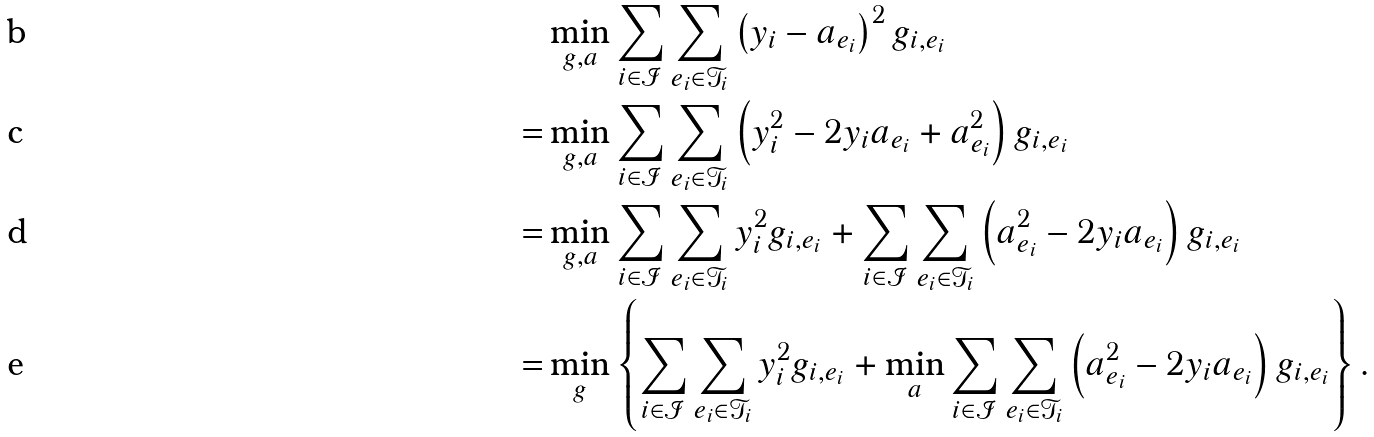<formula> <loc_0><loc_0><loc_500><loc_500>& \min _ { g , a } \sum _ { i \in \mathcal { I } } \sum _ { e _ { i } \in \mathcal { T } _ { i } } \left ( y _ { i } - a _ { e _ { i } } \right ) ^ { 2 } g _ { i , e _ { i } } \\ = & \min _ { g , a } \sum _ { i \in \mathcal { I } } \sum _ { e _ { i } \in \mathcal { T } _ { i } } \left ( y _ { i } ^ { 2 } - 2 y _ { i } a _ { e _ { i } } + a _ { e _ { i } } ^ { 2 } \right ) g _ { i , e _ { i } } \\ = & \min _ { g , a } \sum _ { i \in \mathcal { I } } \sum _ { e _ { i } \in \mathcal { T } _ { i } } y _ { i } ^ { 2 } g _ { i , e _ { i } } + \sum _ { i \in \mathcal { I } } \sum _ { e _ { i } \in \mathcal { T } _ { i } } \left ( a _ { e _ { i } } ^ { 2 } - 2 y _ { i } a _ { e _ { i } } \right ) g _ { i , e _ { i } } \\ = & \min _ { g } \left \{ \sum _ { i \in \mathcal { I } } \sum _ { e _ { i } \in \mathcal { T } _ { i } } y _ { i } ^ { 2 } g _ { i , e _ { i } } + \min _ { a } \sum _ { i \in \mathcal { I } } \sum _ { e _ { i } \in \mathcal { T } _ { i } } \left ( a _ { e _ { i } } ^ { 2 } - 2 y _ { i } a _ { e _ { i } } \right ) g _ { i , e _ { i } } \right \} .</formula> 